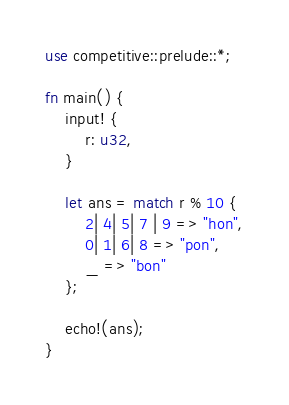<code> <loc_0><loc_0><loc_500><loc_500><_Rust_>use competitive::prelude::*;

fn main() {
    input! {
        r: u32,
    }

    let ans = match r % 10 {
        2| 4| 5| 7 | 9 => "hon",
        0| 1| 6| 8 => "pon",
        _ => "bon"
    };

    echo!(ans);
}</code> 